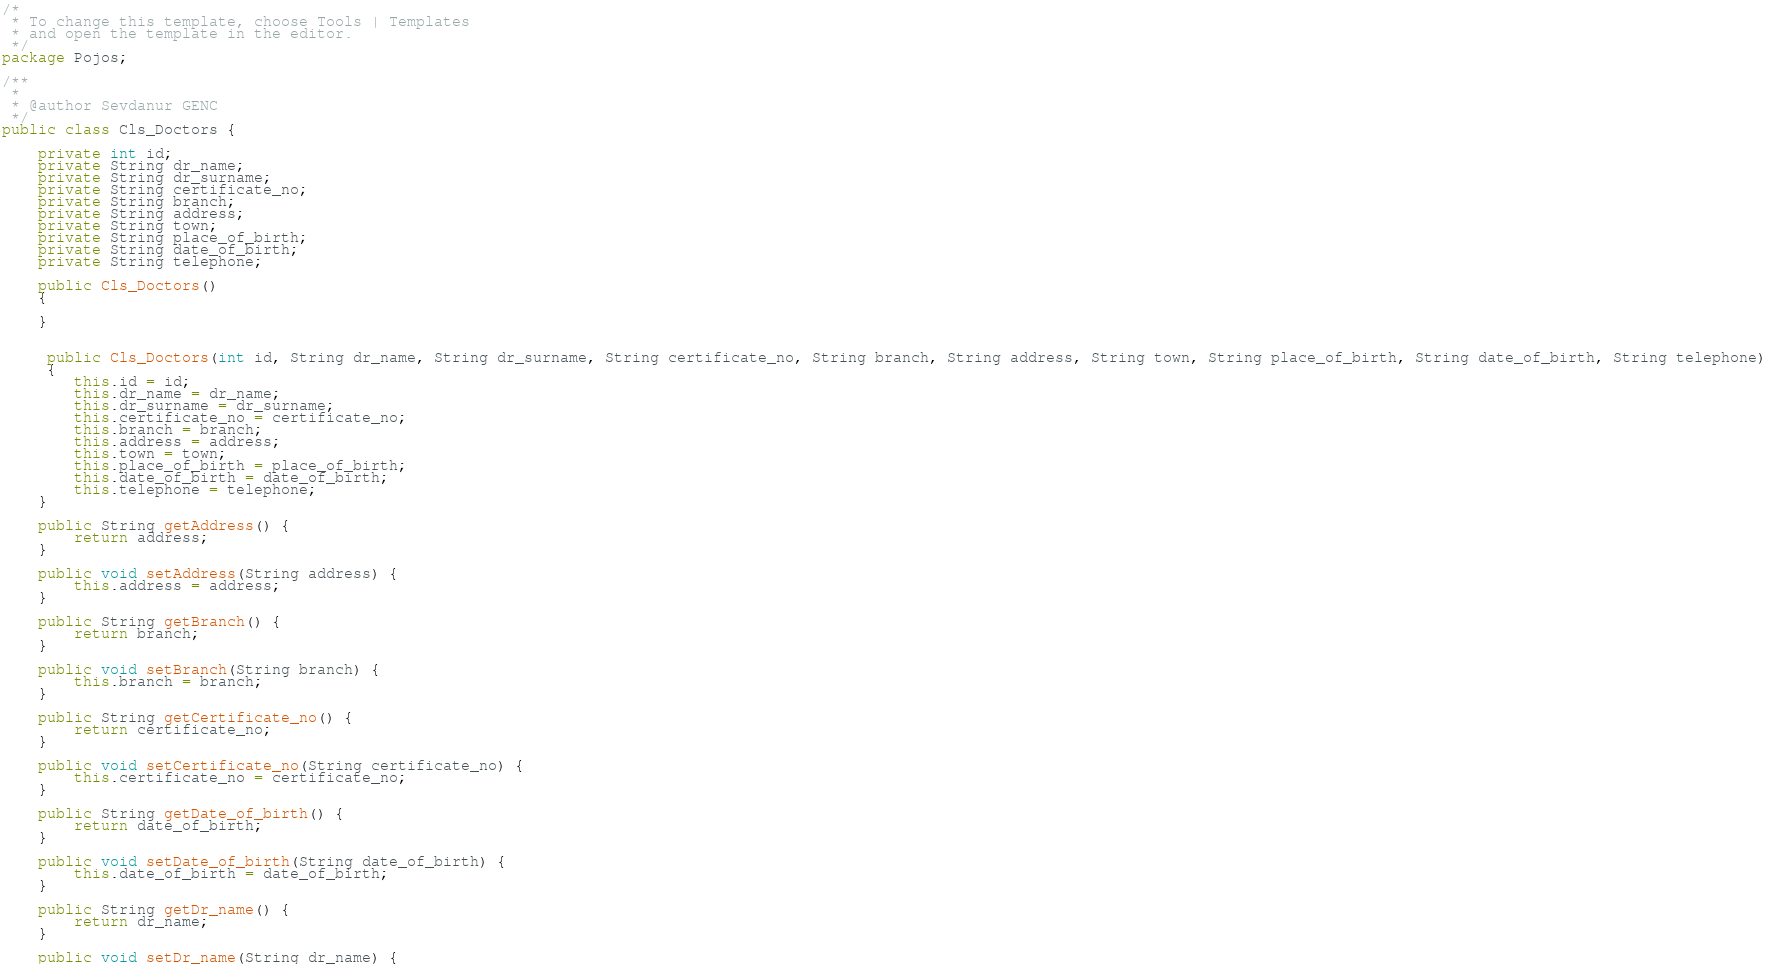Convert code to text. <code><loc_0><loc_0><loc_500><loc_500><_Java_>/*
 * To change this template, choose Tools | Templates
 * and open the template in the editor.
 */
package Pojos;

/**
 *
 * @author Sevdanur GENC
 */
public class Cls_Doctors {
    
    private int id;
    private String dr_name;
    private String dr_surname;
    private String certificate_no;
    private String branch;
    private String address;
    private String town;
    private String place_of_birth;
    private String date_of_birth;
    private String telephone;
    
    public Cls_Doctors()
    {
        
    }
    
    
     public Cls_Doctors(int id, String dr_name, String dr_surname, String certificate_no, String branch, String address, String town, String place_of_birth, String date_of_birth, String telephone) 
     {
        this.id = id;
        this.dr_name = dr_name;
        this.dr_surname = dr_surname;
        this.certificate_no = certificate_no;
        this.branch = branch;
        this.address = address;
        this.town = town;
        this.place_of_birth = place_of_birth;
        this.date_of_birth = date_of_birth;
        this.telephone = telephone;
    }

    public String getAddress() {
        return address;
    }

    public void setAddress(String address) {
        this.address = address;
    }

    public String getBranch() {
        return branch;
    }

    public void setBranch(String branch) {
        this.branch = branch;
    }

    public String getCertificate_no() {
        return certificate_no;
    }

    public void setCertificate_no(String certificate_no) {
        this.certificate_no = certificate_no;
    }

    public String getDate_of_birth() {
        return date_of_birth;
    }

    public void setDate_of_birth(String date_of_birth) {
        this.date_of_birth = date_of_birth;
    }

    public String getDr_name() {
        return dr_name;
    }

    public void setDr_name(String dr_name) {</code> 